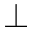Convert formula to latex. <formula><loc_0><loc_0><loc_500><loc_500>\bot</formula> 